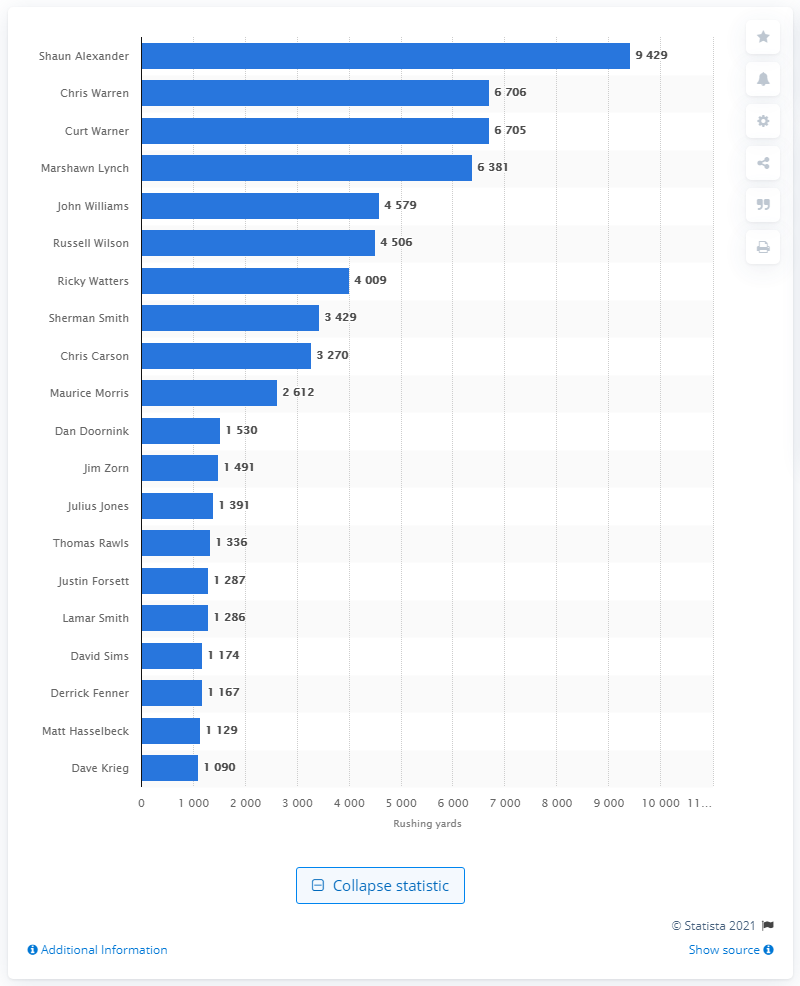Specify some key components in this picture. Shaun Alexander is the career rushing leader of the Seattle Seahawks. 